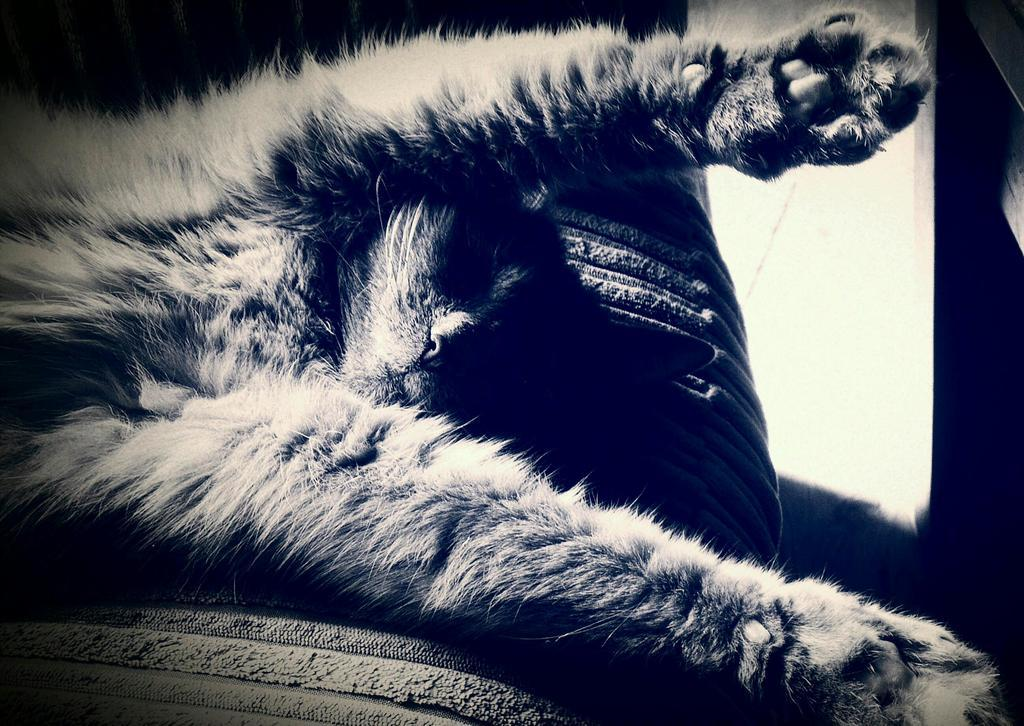What is the color scheme of the image? The image is in black and white. What type of animal can be seen in the image? There is a cat in the image. What type of oil is being used by the cat in the image? There is no oil present in the image, and the cat is not using any oil. What type of iron object is visible in the image? There is no iron object present in the image. 